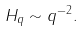Convert formula to latex. <formula><loc_0><loc_0><loc_500><loc_500>H _ { q } \sim q ^ { - 2 } .</formula> 